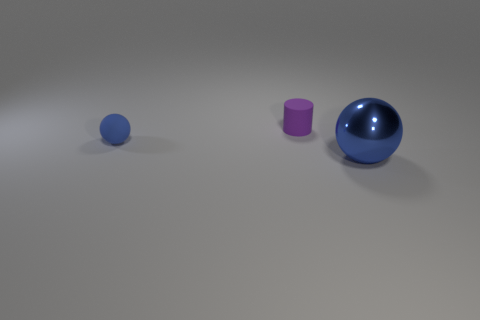Is the color of the object in front of the blue matte object the same as the small object that is to the left of the tiny purple object?
Ensure brevity in your answer.  Yes. What number of blue objects have the same size as the purple thing?
Make the answer very short. 1. There is another thing that is the same color as the large object; what size is it?
Offer a very short reply. Small. How many tiny objects are brown metallic balls or purple things?
Offer a terse response. 1. How many blue things are there?
Provide a short and direct response. 2. Are there an equal number of big balls that are in front of the large blue object and balls in front of the matte ball?
Make the answer very short. No. Are there any small rubber things to the left of the small purple matte thing?
Provide a succinct answer. Yes. There is a sphere left of the big blue object; what is its color?
Provide a succinct answer. Blue. The blue object on the right side of the small purple matte object behind the big blue shiny object is made of what material?
Ensure brevity in your answer.  Metal. Are there fewer things on the right side of the small blue thing than spheres to the right of the large blue shiny object?
Give a very brief answer. No. 